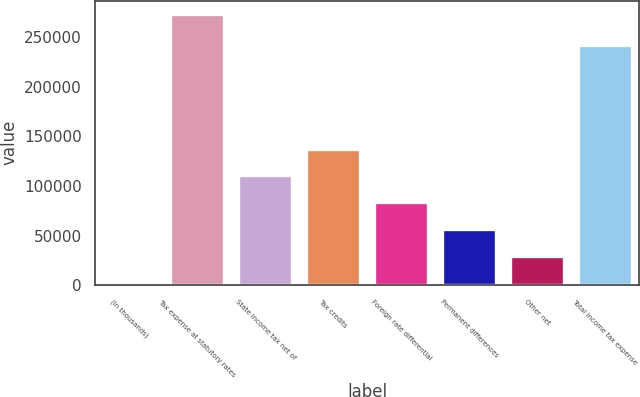<chart> <loc_0><loc_0><loc_500><loc_500><bar_chart><fcel>(In thousands)<fcel>Tax expense at statutory rates<fcel>State income tax net of<fcel>Tax credits<fcel>Foreign rate differential<fcel>Permanent differences<fcel>Other net<fcel>Total income tax expense<nl><fcel>2015<fcel>273483<fcel>110602<fcel>137749<fcel>83455.4<fcel>56308.6<fcel>29161.8<fcel>242018<nl></chart> 